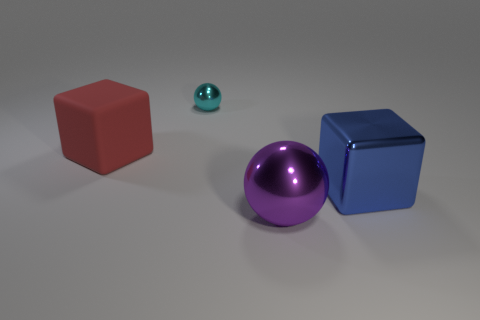What material is the sphere that is to the right of the metallic thing behind the large rubber block?
Make the answer very short. Metal. Are there the same number of big purple metallic objects that are in front of the purple sphere and large gray rubber things?
Offer a terse response. Yes. Are there any other things that have the same material as the large red object?
Your answer should be very brief. No. What number of objects are on the right side of the large rubber cube and left of the blue cube?
Make the answer very short. 2. How many other objects are the same shape as the cyan metallic thing?
Keep it short and to the point. 1. Is the number of objects that are behind the big blue metallic object greater than the number of cyan shiny balls?
Provide a short and direct response. Yes. The sphere that is in front of the big blue shiny cube is what color?
Ensure brevity in your answer.  Purple. How many metallic things are either big yellow blocks or large red blocks?
Your answer should be compact. 0. Is there a object that is on the right side of the big red thing to the left of the block that is right of the red block?
Provide a succinct answer. Yes. How many objects are in front of the big red thing?
Your answer should be very brief. 2. 